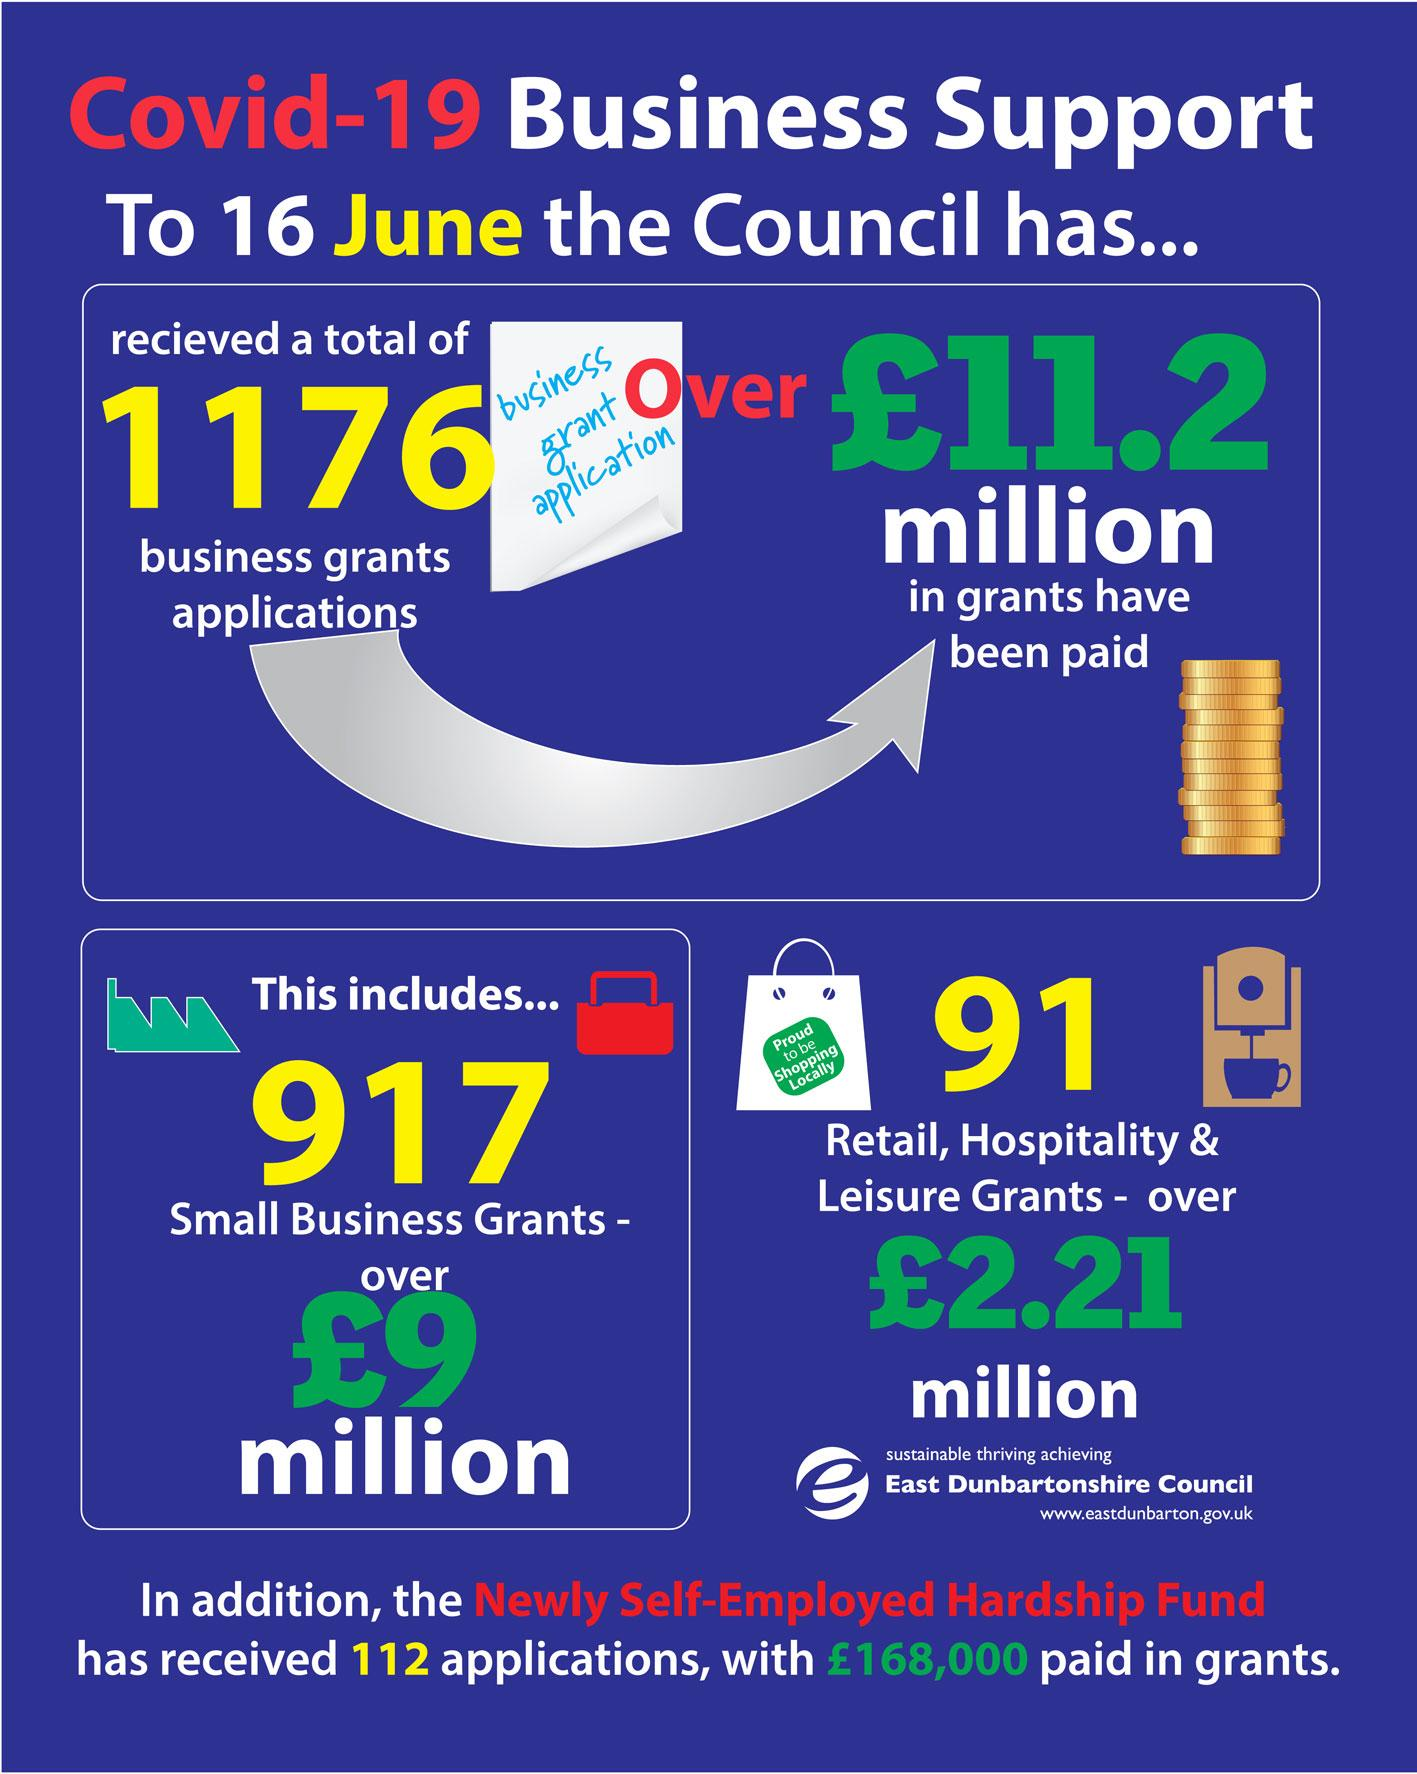Highlight a few significant elements in this photo. As of 16 June, the East Dunbartonshire Council had received 917 applications for small business grants. As of June 16th, the total number of business grant applications received by the East Dunbartonshire Council is 1176. As of 16 June, the total amount of grants paid by the East Dunbartonshire Council is over £11.2 million. 